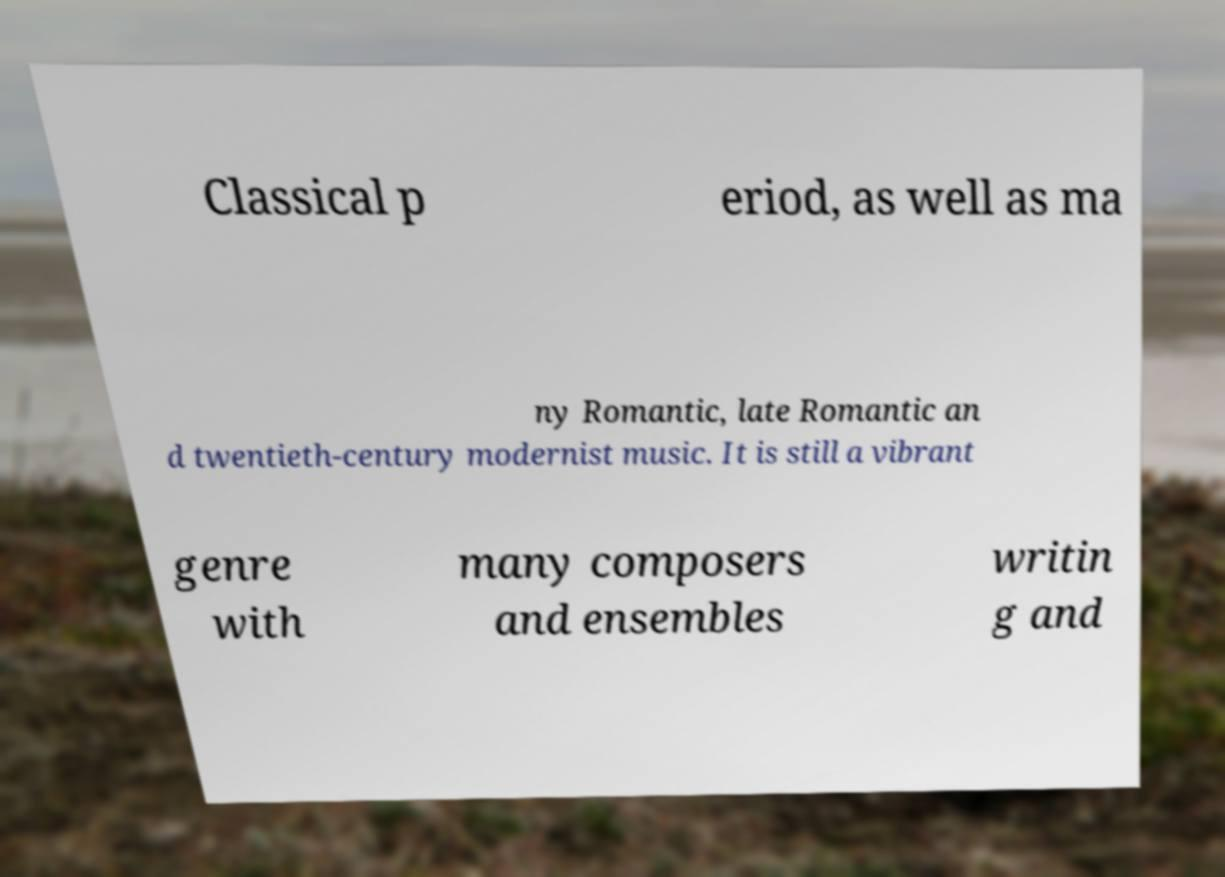I need the written content from this picture converted into text. Can you do that? Classical p eriod, as well as ma ny Romantic, late Romantic an d twentieth-century modernist music. It is still a vibrant genre with many composers and ensembles writin g and 